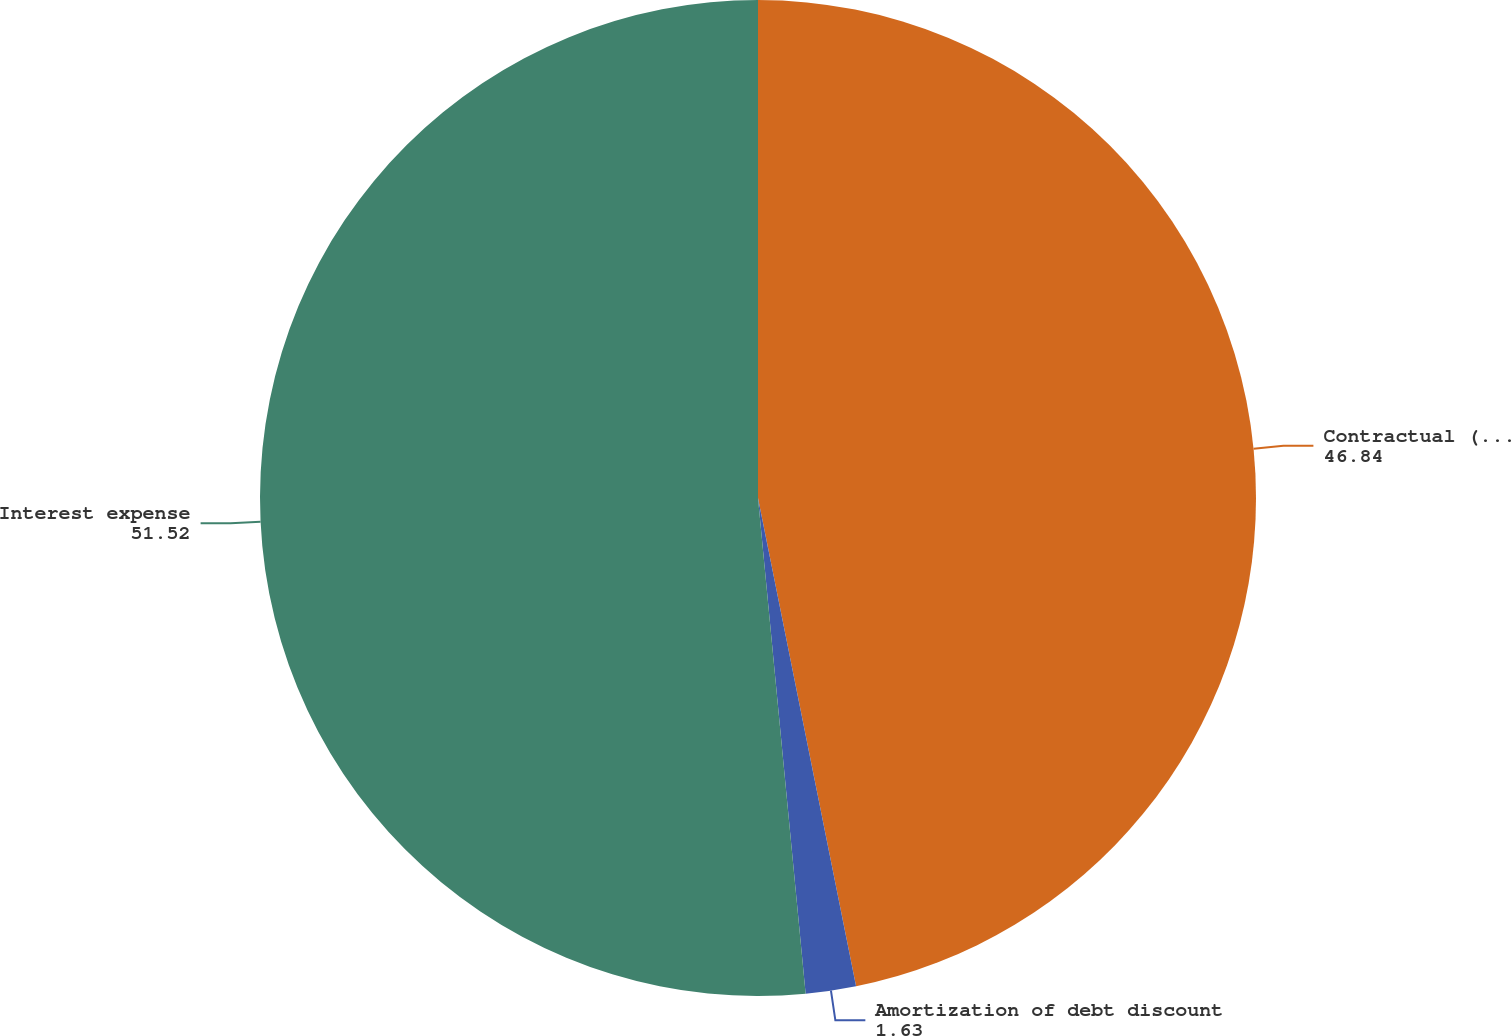<chart> <loc_0><loc_0><loc_500><loc_500><pie_chart><fcel>Contractual (stated) interest<fcel>Amortization of debt discount<fcel>Interest expense<nl><fcel>46.84%<fcel>1.63%<fcel>51.52%<nl></chart> 